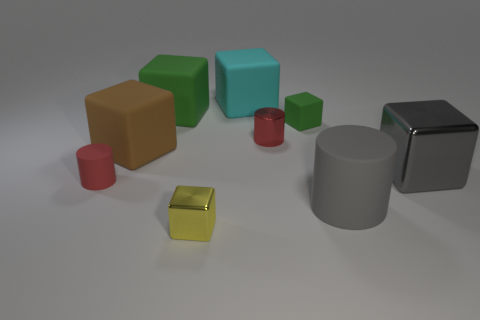Subtract all big gray metallic cubes. How many cubes are left? 5 Subtract all gray blocks. How many blocks are left? 5 Subtract all gray cubes. Subtract all red cylinders. How many cubes are left? 5 Subtract all cylinders. How many objects are left? 6 Add 1 big green objects. How many objects exist? 10 Add 2 large metal objects. How many large metal objects are left? 3 Add 8 purple spheres. How many purple spheres exist? 8 Subtract 1 yellow blocks. How many objects are left? 8 Subtract all gray cubes. Subtract all cyan matte cubes. How many objects are left? 7 